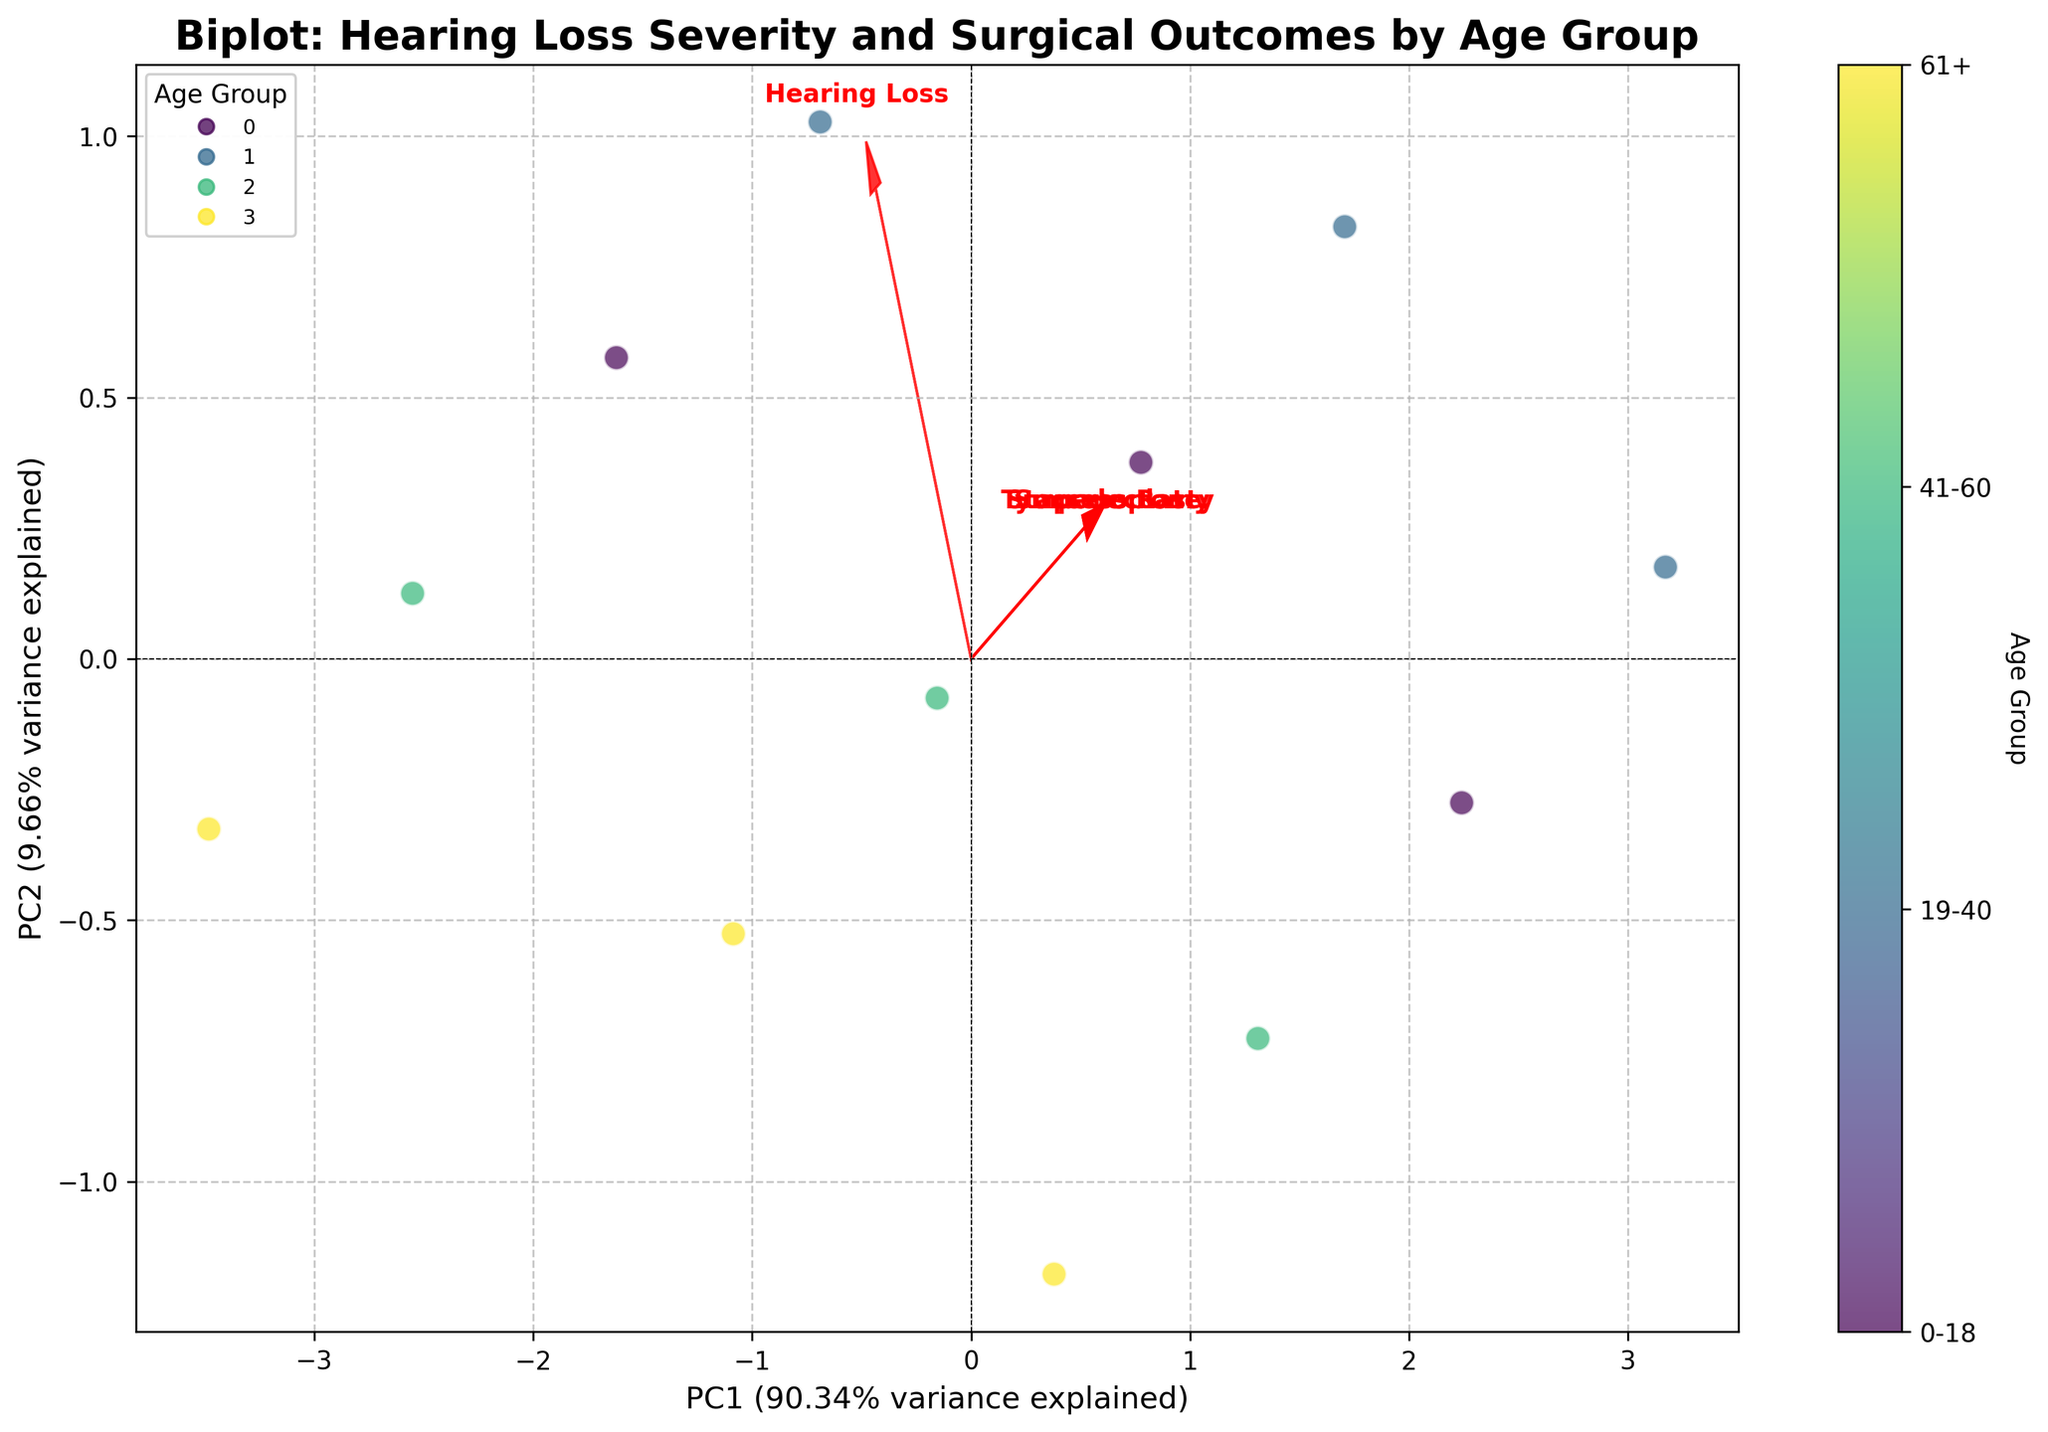What's the title of the figure? The title is shown at the top of the figure and describes the main subject. It reads "Biplot: Hearing Loss Severity and Surgical Outcomes by Age Group".
Answer: Biplot: Hearing Loss Severity and Surgical Outcomes by Age Group What do the axes represent in this biplot? The axes are labeled with their respective directions and variances explained. The x-axis is labeled "PC1" and y-axis is labeled "PC2", representing the first and second principal components, respectively.
Answer: PC1 and PC2 Which age group tends to have higher PC1 values? By looking at the distribution of data points and their colors on the figure, the age group with the highest cluster towards the right (positive side) of PC1 can be identified. Based on the color gradient, the age group with higher PC1 values is 19-40.
Answer: 19-40 Which feature vector points most strongly in the direction of PC2? The feature vectors are represented by arrows. The feature vector with the longest arrow in the y-axis direction (PC2) is the "Tympanoplasty".
Answer: Tympanoplasty Which age group tends to have lower PC2 values? The data points' positions and their colors showing the age groups indicate that the age group clustered towards the more negative side of PC2 is 61+.
Answer: 61+ How is the 'Stapedectomy' outcome represented in this biplot? The 'Stapedectomy' outcome is represented as one of the feature vectors (arrows) in the biplot. Its arrow points towards the bottom-right quadrant, indicating how it correlates with PC1 and PC2.
Answer: As an arrow pointing bottom-right Between 'Tympanoplasty' and 'Stapedectomy,' which is more aligned with PC1? By observing the directions of the arrows for these two features, 'Stapedectomy' appears to align more closely with the horizontal axis (PC1) than 'Tympanoplasty'.
Answer: Stapedectomy Which age group shows the widest spread in the biplot? Examining the spread of data points for each age group's color reveals that the age group 0-18 spans a larger area across both PC axes compared to other age groups.
Answer: 0-18 What percentage of the variance is explained by PC1? The percentage of the variance explained by PC1 is provided in the axis label for PC1. It is 62%.
Answer: 62% Considering 'Hearing Loss' and 'Success Rate,' which aligns more with PC2? By examining the direction and positioning of the arrows, 'Hearing Loss' points more in the vertical direction alongside PC2, while 'Success Rate' aligns more horizontally, indicating 'Hearing Loss' aligns more with PC2.
Answer: Hearing Loss 